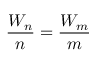Convert formula to latex. <formula><loc_0><loc_0><loc_500><loc_500>{ \frac { W _ { n } } { n } } = { \frac { W _ { m } } { m } }</formula> 